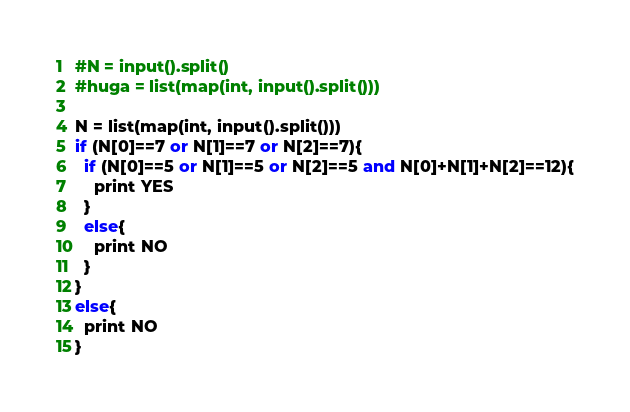Convert code to text. <code><loc_0><loc_0><loc_500><loc_500><_Python_>#N = input().split()
#huga = list(map(int, input().split()))

N = list(map(int, input().split()))
if (N[0]==7 or N[1]==7 or N[2]==7){
  if (N[0]==5 or N[1]==5 or N[2]==5 and N[0]+N[1]+N[2]==12){
    print YES
  }
  else{
  	print NO
  }
}
else{
  print NO
}</code> 